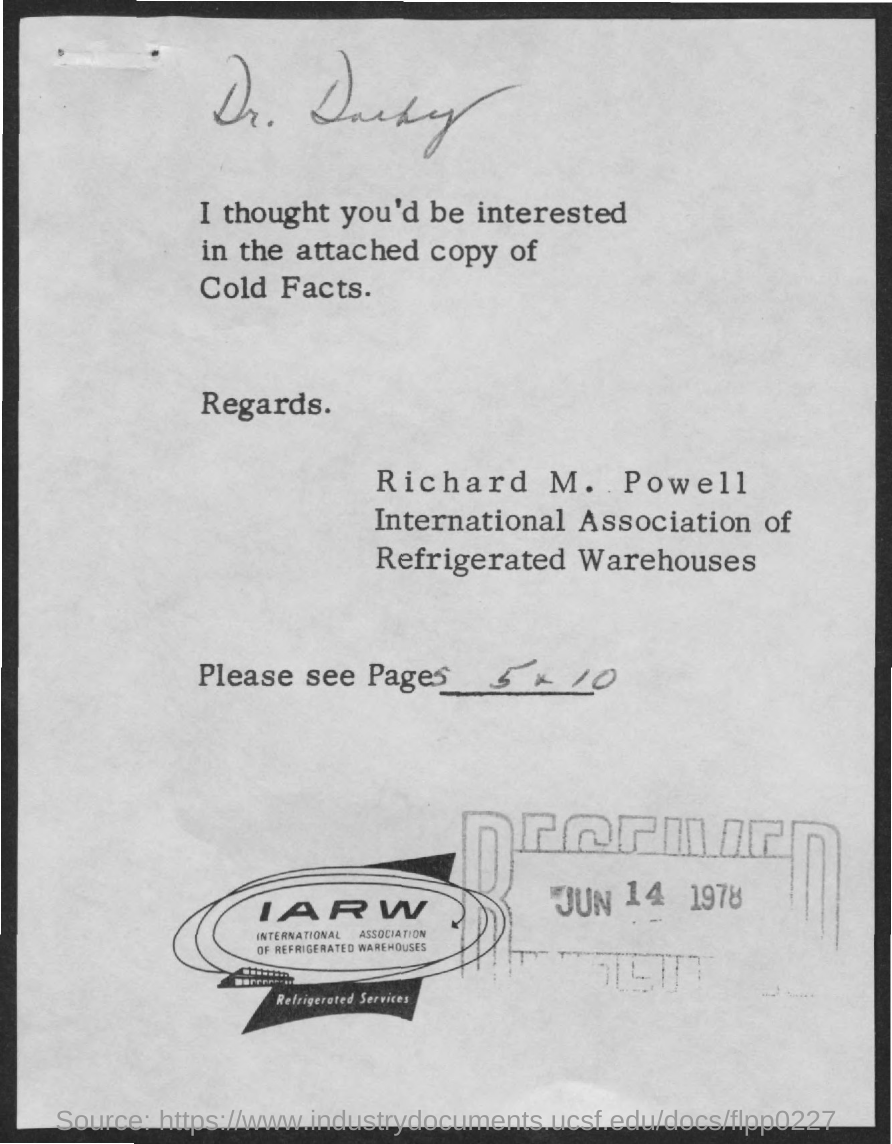What is the received date mentioned ?
Your answer should be compact. JUN 14 1978. What are the page no. mentioned  ?
Your answer should be very brief. 5-10. What is the full form of iarw?
Offer a terse response. International Association of Refrigerated Warehouses. 